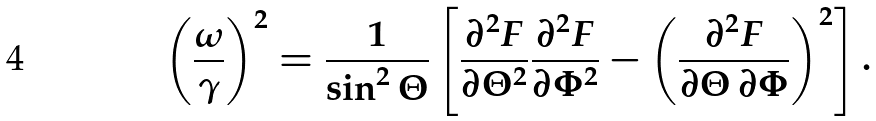<formula> <loc_0><loc_0><loc_500><loc_500>\left ( \frac { \omega } { \gamma } \right ) ^ { 2 } = \frac { 1 } { \sin ^ { 2 } \Theta } \left [ \frac { \partial ^ { 2 } F } { \partial \Theta ^ { 2 } } \frac { \partial ^ { 2 } F } { \partial \Phi ^ { 2 } } - \left ( \frac { \partial ^ { 2 } F } { \partial \Theta \, \partial \Phi } \right ) ^ { 2 } \right ] .</formula> 